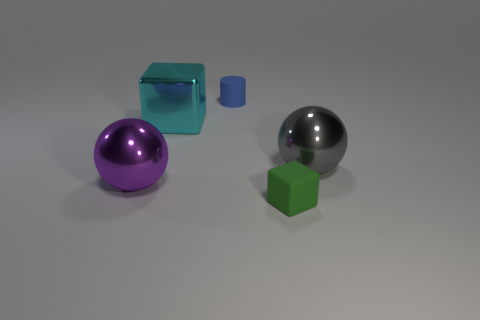What is the material of the other object that is the same size as the blue object?
Offer a very short reply. Rubber. Is there a matte cube that has the same size as the blue cylinder?
Your answer should be compact. Yes. What is the color of the small rubber thing that is in front of the large purple shiny thing?
Your answer should be compact. Green. There is a large metal thing that is right of the tiny blue rubber object; is there a rubber object that is in front of it?
Offer a terse response. Yes. How many other objects are the same color as the small cylinder?
Your answer should be compact. 0. Is the size of the gray thing that is right of the purple sphere the same as the block that is behind the small rubber cube?
Offer a terse response. Yes. How big is the rubber thing that is left of the small object that is on the right side of the blue rubber object?
Offer a very short reply. Small. The object that is right of the large block and left of the green object is made of what material?
Your answer should be very brief. Rubber. The rubber block is what color?
Give a very brief answer. Green. There is a matte thing that is on the left side of the tiny green rubber thing; what shape is it?
Provide a short and direct response. Cylinder. 